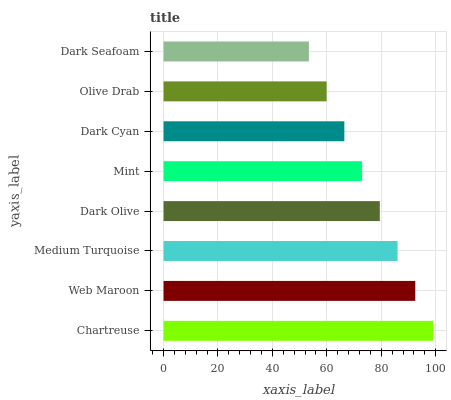Is Dark Seafoam the minimum?
Answer yes or no. Yes. Is Chartreuse the maximum?
Answer yes or no. Yes. Is Web Maroon the minimum?
Answer yes or no. No. Is Web Maroon the maximum?
Answer yes or no. No. Is Chartreuse greater than Web Maroon?
Answer yes or no. Yes. Is Web Maroon less than Chartreuse?
Answer yes or no. Yes. Is Web Maroon greater than Chartreuse?
Answer yes or no. No. Is Chartreuse less than Web Maroon?
Answer yes or no. No. Is Dark Olive the high median?
Answer yes or no. Yes. Is Mint the low median?
Answer yes or no. Yes. Is Medium Turquoise the high median?
Answer yes or no. No. Is Dark Seafoam the low median?
Answer yes or no. No. 